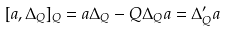Convert formula to latex. <formula><loc_0><loc_0><loc_500><loc_500>[ a , \Delta _ { Q } ] _ { Q } = a \Delta _ { Q } - Q \Delta _ { Q } a = \Delta ^ { \prime } _ { Q } a</formula> 